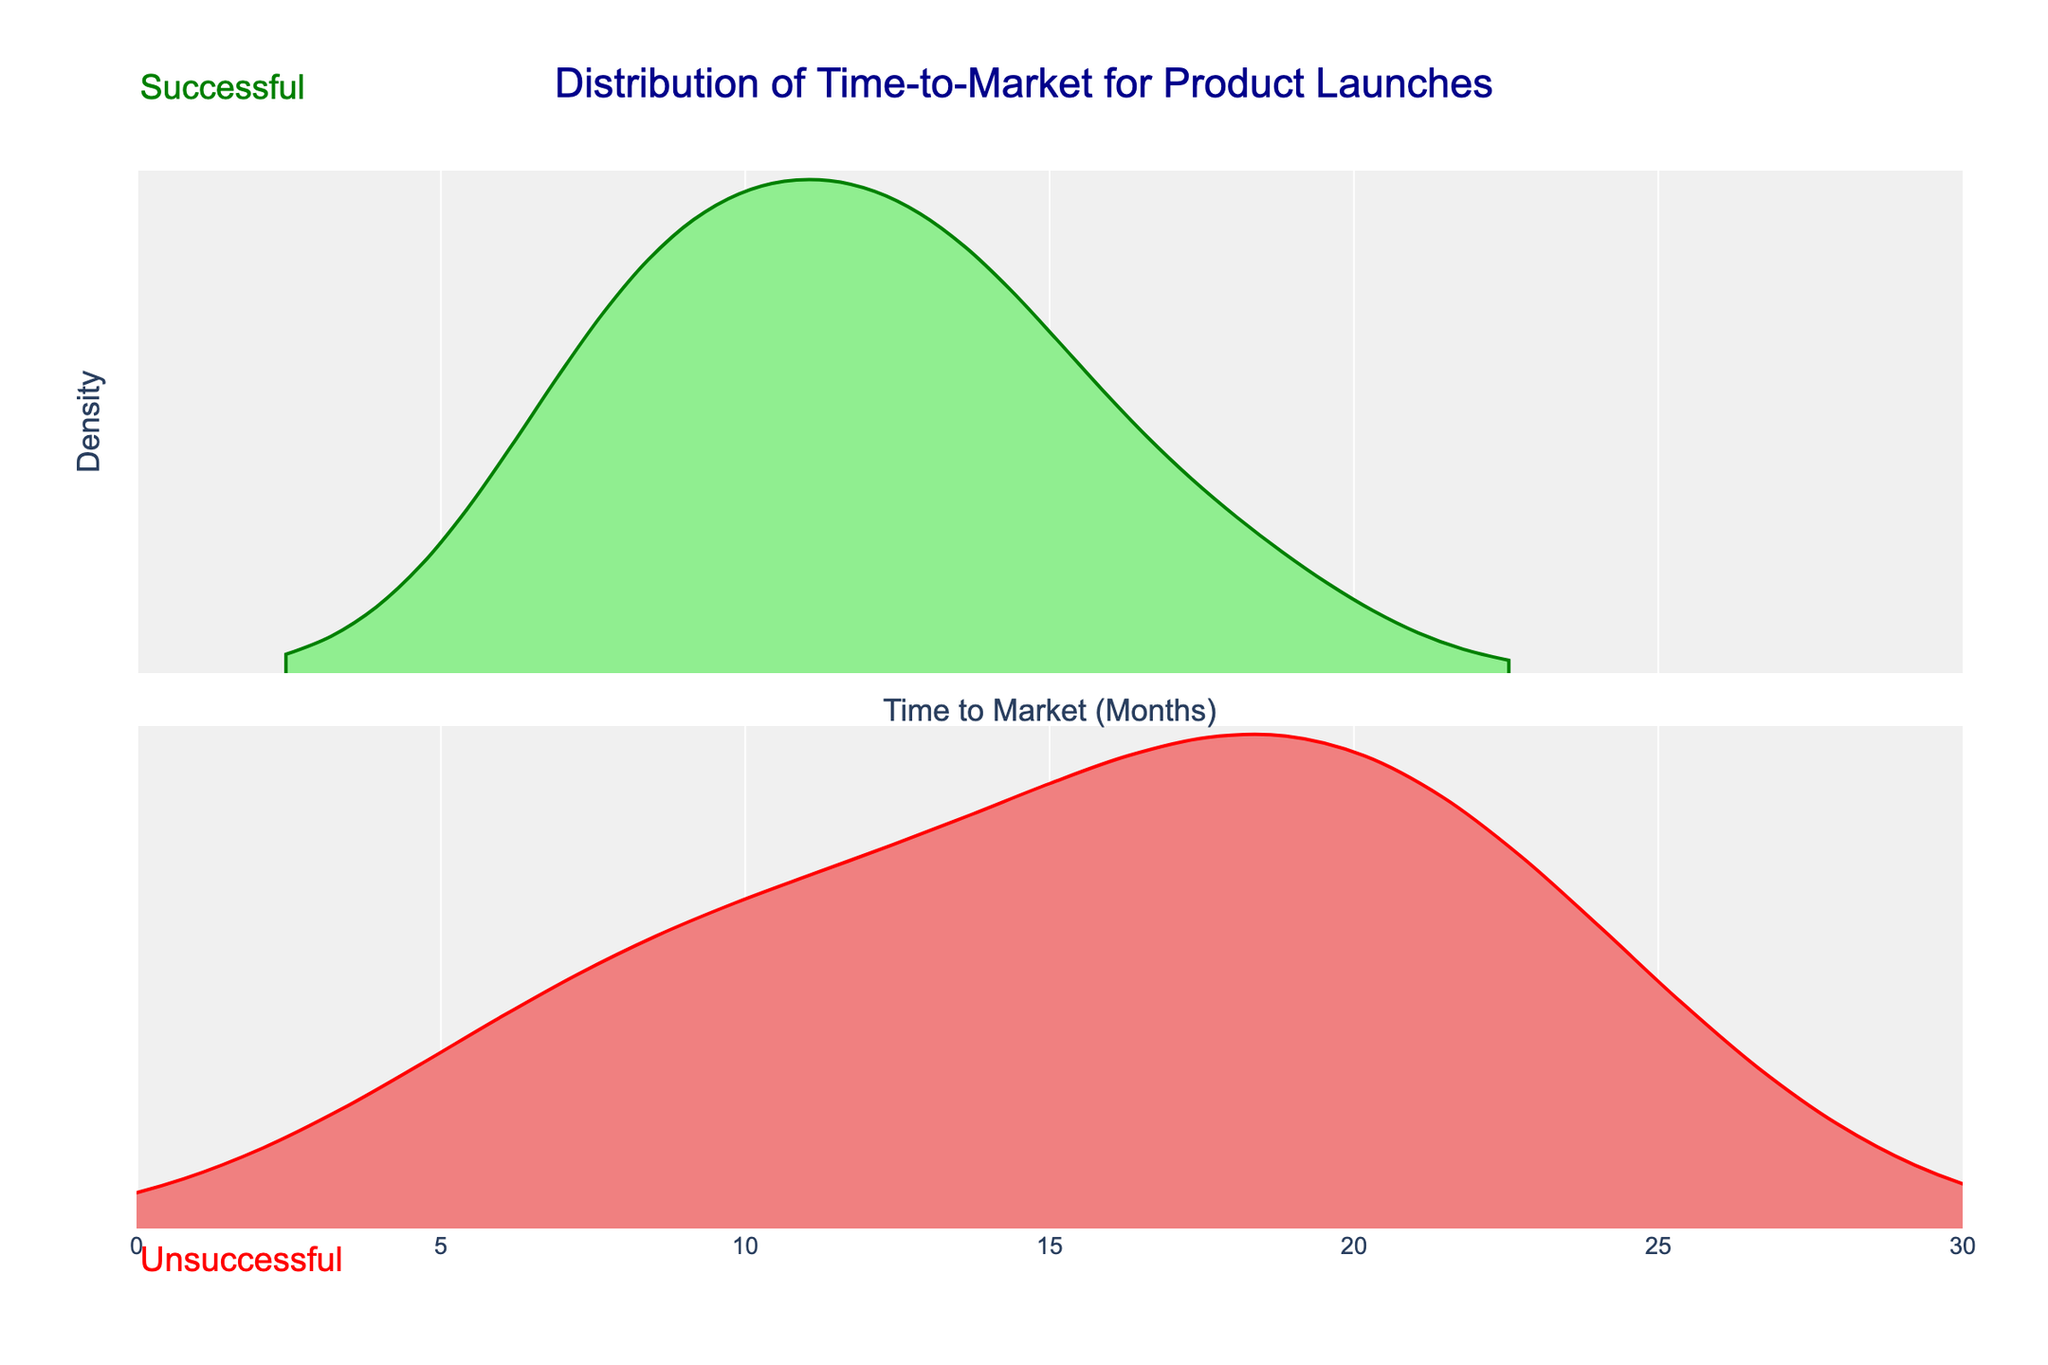What is the title of the figure? The title of the figure is displayed at the top and it reads "Distribution of Time-to-Market for Product Launches."
Answer: Distribution of Time-to-Market for Product Launches What are the x-axis and y-axis titles? The x-axis title is "Time to Market (Months)" and the y-axis title is "Density."
Answer: Time to Market (Months), Density What colors represent successful and unsuccessful products? The color green represents successful products, and the color red represents unsuccessful products, as indicated by the annotations and the colors used in the density plots.
Answer: Green, Red Where do successful product launches tend to cluster in terms of time-to-market? By examining the plot, successful product launches tend to cluster around the 10 to 15 months region, as indicated by the higher density in that range.
Answer: 10 to 15 months Which group has a longer range of time-to-market, successful or unsuccessful product launches? Unsuccessful product launches have a longer range, with values extending up to 24 months, whereas successful launches are more concentrated with a smaller range.
Answer: Unsuccessful product launches What is the maximum time-to-market for successful product launches? By looking at the upper boundary of the successful product density plot, the maximum time-to-market for successful product launches is 18 months.
Answer: 18 months Do any unsuccessful product launches have a time-to-market shorter than 10 months? Yes, the figure shows a density for unsuccessful products starting as low as 6 months, evident from the plot.
Answer: Yes Which group shows higher density peaks, successful or unsuccessful, and around which months? Successful products show higher density peaks around 10 to 12 months, while unsuccessful products exhibit lower peaks across a broader range.
Answer: Successful, around 10 to 12 months How does the density spread differ between successful and unsuccessful product launches? Successful product launches show a more concentrated density around a narrower range (10-12 months), whereas unsuccessful product launches have a more spread-out density, indicating varied time-to-market lengths extending up to 24 months.
Answer: Successful: Concentrated; Unsuccessful: Varied What insights can you draw about the time-to-market impact on product success from the figure? The figure suggests that a more concentrated, shorter time-to-market (around 10-12 months) is associated with successful products, while a wider, longer time-to-market is linked to unsuccessful products.
Answer: Shorter time-to-market linked to success, longer linked to failure 